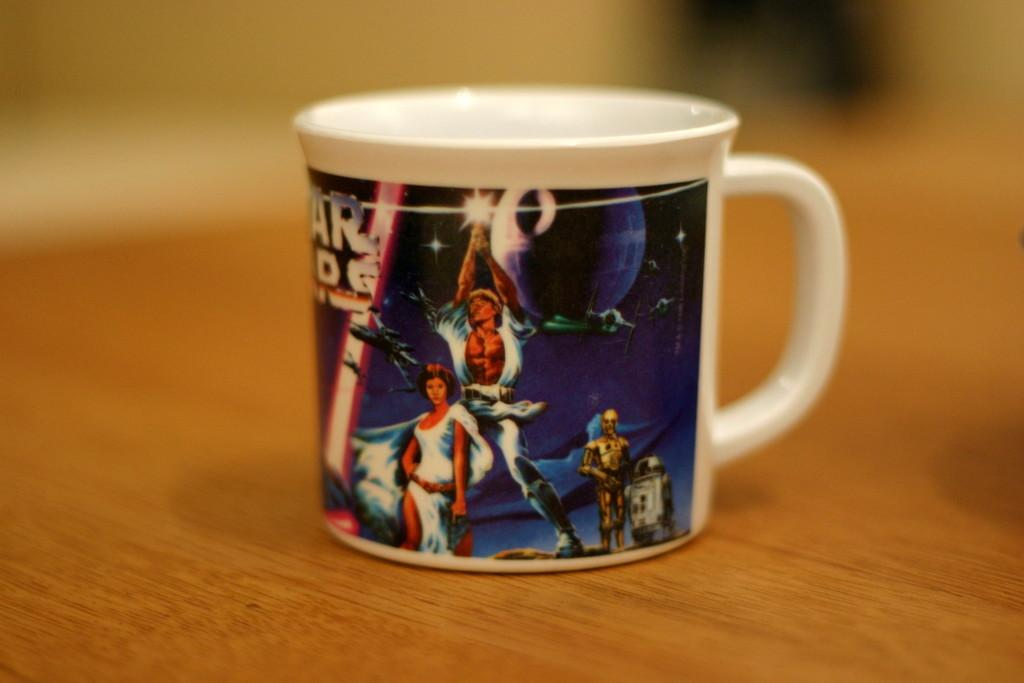What type of surface is visible in the image? There is a wooden surface in the image. What object is placed on the wooden surface? There is a cup on the wooden surface. What can be observed on the cup? The cup has images on it and text on it. What type of fly is sitting on the rim of the cup in the image? There is no fly present on the cup or in the image. 